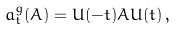Convert formula to latex. <formula><loc_0><loc_0><loc_500><loc_500>\ a ^ { g } _ { t } ( A ) = U ( - t ) A U ( t ) \, ,</formula> 